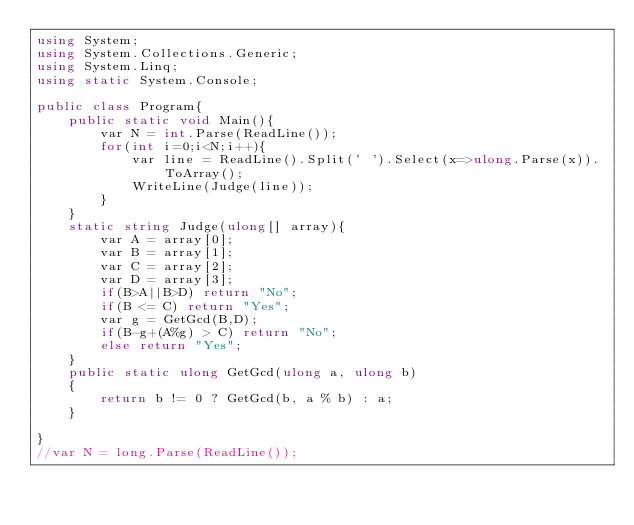Convert code to text. <code><loc_0><loc_0><loc_500><loc_500><_C#_>using System;
using System.Collections.Generic;
using System.Linq;
using static System.Console;

public class Program{
    public static void Main(){
        var N = int.Parse(ReadLine());
        for(int i=0;i<N;i++){
            var line = ReadLine().Split(' ').Select(x=>ulong.Parse(x)).ToArray();
            WriteLine(Judge(line));
        }
    }
    static string Judge(ulong[] array){
        var A = array[0];
        var B = array[1];
        var C = array[2];
        var D = array[3];
        if(B>A||B>D) return "No";
        if(B <= C) return "Yes";
        var g = GetGcd(B,D);
        if(B-g+(A%g) > C) return "No";
        else return "Yes";
    }
    public static ulong GetGcd(ulong a, ulong b)
    {
        return b != 0 ? GetGcd(b, a % b) : a;
    }

}
//var N = long.Parse(ReadLine());
</code> 